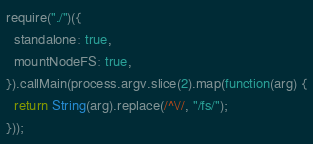Convert code to text. <code><loc_0><loc_0><loc_500><loc_500><_JavaScript_>
require("./")({
  standalone: true,
  mountNodeFS: true,
}).callMain(process.argv.slice(2).map(function(arg) {
  return String(arg).replace(/^\//, "/fs/");
}));
</code> 